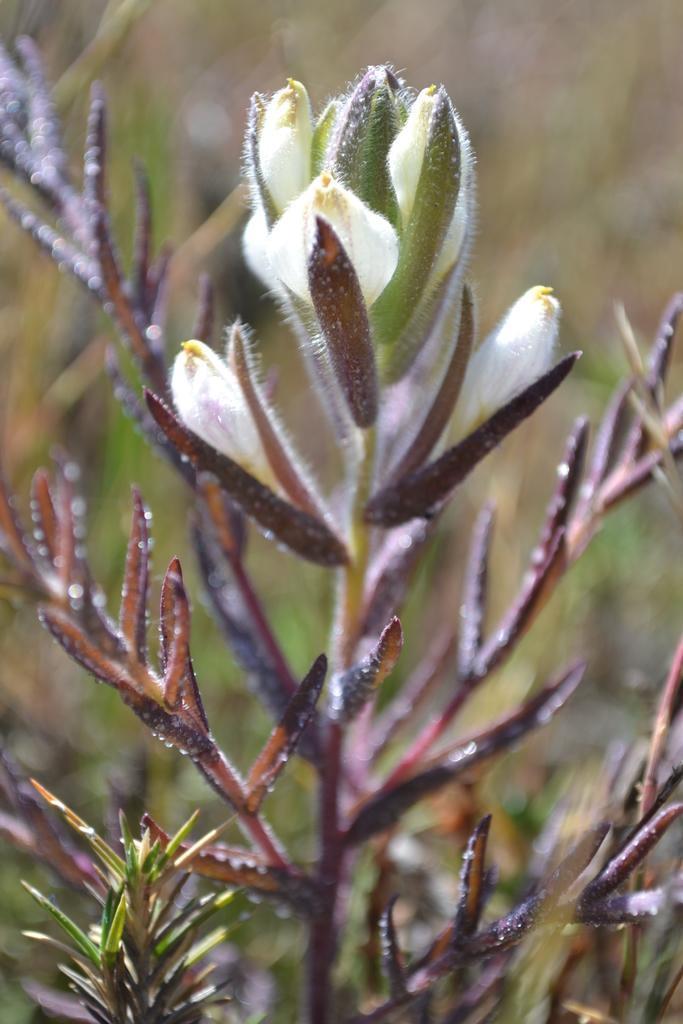In one or two sentences, can you explain what this image depicts? In this picture, we can see plants, flowers, and the blurred background. 